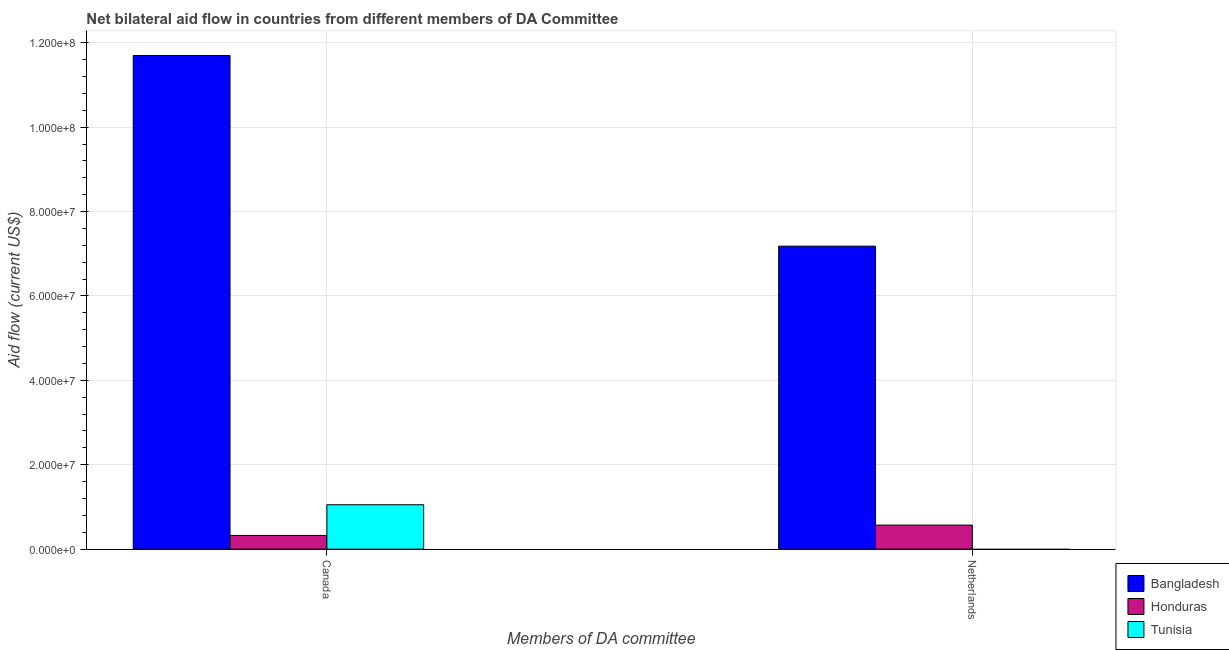How many groups of bars are there?
Provide a succinct answer. 2. How many bars are there on the 2nd tick from the left?
Ensure brevity in your answer.  2. What is the amount of aid given by netherlands in Honduras?
Provide a short and direct response. 5.70e+06. Across all countries, what is the maximum amount of aid given by canada?
Provide a succinct answer. 1.17e+08. Across all countries, what is the minimum amount of aid given by canada?
Your answer should be very brief. 3.25e+06. What is the total amount of aid given by netherlands in the graph?
Offer a very short reply. 7.75e+07. What is the difference between the amount of aid given by canada in Tunisia and that in Honduras?
Give a very brief answer. 7.27e+06. What is the difference between the amount of aid given by netherlands in Tunisia and the amount of aid given by canada in Bangladesh?
Offer a terse response. -1.17e+08. What is the average amount of aid given by netherlands per country?
Ensure brevity in your answer.  2.58e+07. What is the difference between the amount of aid given by canada and amount of aid given by netherlands in Honduras?
Offer a terse response. -2.45e+06. In how many countries, is the amount of aid given by canada greater than 48000000 US$?
Offer a very short reply. 1. What is the ratio of the amount of aid given by netherlands in Bangladesh to that in Honduras?
Give a very brief answer. 12.6. Is the amount of aid given by canada in Bangladesh less than that in Tunisia?
Keep it short and to the point. No. In how many countries, is the amount of aid given by netherlands greater than the average amount of aid given by netherlands taken over all countries?
Offer a very short reply. 1. Are all the bars in the graph horizontal?
Offer a terse response. No. Are the values on the major ticks of Y-axis written in scientific E-notation?
Your response must be concise. Yes. Does the graph contain any zero values?
Your response must be concise. Yes. Does the graph contain grids?
Provide a succinct answer. Yes. Where does the legend appear in the graph?
Offer a very short reply. Bottom right. How are the legend labels stacked?
Give a very brief answer. Vertical. What is the title of the graph?
Your response must be concise. Net bilateral aid flow in countries from different members of DA Committee. Does "Congo (Democratic)" appear as one of the legend labels in the graph?
Your response must be concise. No. What is the label or title of the X-axis?
Offer a very short reply. Members of DA committee. What is the label or title of the Y-axis?
Provide a short and direct response. Aid flow (current US$). What is the Aid flow (current US$) of Bangladesh in Canada?
Your response must be concise. 1.17e+08. What is the Aid flow (current US$) of Honduras in Canada?
Provide a short and direct response. 3.25e+06. What is the Aid flow (current US$) of Tunisia in Canada?
Your answer should be very brief. 1.05e+07. What is the Aid flow (current US$) of Bangladesh in Netherlands?
Provide a short and direct response. 7.18e+07. What is the Aid flow (current US$) in Honduras in Netherlands?
Offer a very short reply. 5.70e+06. Across all Members of DA committee, what is the maximum Aid flow (current US$) of Bangladesh?
Your answer should be very brief. 1.17e+08. Across all Members of DA committee, what is the maximum Aid flow (current US$) of Honduras?
Provide a short and direct response. 5.70e+06. Across all Members of DA committee, what is the maximum Aid flow (current US$) in Tunisia?
Your response must be concise. 1.05e+07. Across all Members of DA committee, what is the minimum Aid flow (current US$) of Bangladesh?
Your response must be concise. 7.18e+07. Across all Members of DA committee, what is the minimum Aid flow (current US$) in Honduras?
Make the answer very short. 3.25e+06. Across all Members of DA committee, what is the minimum Aid flow (current US$) of Tunisia?
Offer a very short reply. 0. What is the total Aid flow (current US$) in Bangladesh in the graph?
Your response must be concise. 1.89e+08. What is the total Aid flow (current US$) in Honduras in the graph?
Ensure brevity in your answer.  8.95e+06. What is the total Aid flow (current US$) in Tunisia in the graph?
Ensure brevity in your answer.  1.05e+07. What is the difference between the Aid flow (current US$) in Bangladesh in Canada and that in Netherlands?
Ensure brevity in your answer.  4.52e+07. What is the difference between the Aid flow (current US$) in Honduras in Canada and that in Netherlands?
Offer a terse response. -2.45e+06. What is the difference between the Aid flow (current US$) of Bangladesh in Canada and the Aid flow (current US$) of Honduras in Netherlands?
Your response must be concise. 1.11e+08. What is the average Aid flow (current US$) in Bangladesh per Members of DA committee?
Give a very brief answer. 9.44e+07. What is the average Aid flow (current US$) of Honduras per Members of DA committee?
Your response must be concise. 4.48e+06. What is the average Aid flow (current US$) of Tunisia per Members of DA committee?
Offer a very short reply. 5.26e+06. What is the difference between the Aid flow (current US$) of Bangladesh and Aid flow (current US$) of Honduras in Canada?
Your response must be concise. 1.14e+08. What is the difference between the Aid flow (current US$) in Bangladesh and Aid flow (current US$) in Tunisia in Canada?
Make the answer very short. 1.06e+08. What is the difference between the Aid flow (current US$) in Honduras and Aid flow (current US$) in Tunisia in Canada?
Offer a terse response. -7.27e+06. What is the difference between the Aid flow (current US$) of Bangladesh and Aid flow (current US$) of Honduras in Netherlands?
Your answer should be compact. 6.61e+07. What is the ratio of the Aid flow (current US$) of Bangladesh in Canada to that in Netherlands?
Offer a terse response. 1.63. What is the ratio of the Aid flow (current US$) of Honduras in Canada to that in Netherlands?
Your answer should be compact. 0.57. What is the difference between the highest and the second highest Aid flow (current US$) in Bangladesh?
Provide a succinct answer. 4.52e+07. What is the difference between the highest and the second highest Aid flow (current US$) of Honduras?
Ensure brevity in your answer.  2.45e+06. What is the difference between the highest and the lowest Aid flow (current US$) of Bangladesh?
Your response must be concise. 4.52e+07. What is the difference between the highest and the lowest Aid flow (current US$) of Honduras?
Offer a terse response. 2.45e+06. What is the difference between the highest and the lowest Aid flow (current US$) of Tunisia?
Your answer should be very brief. 1.05e+07. 